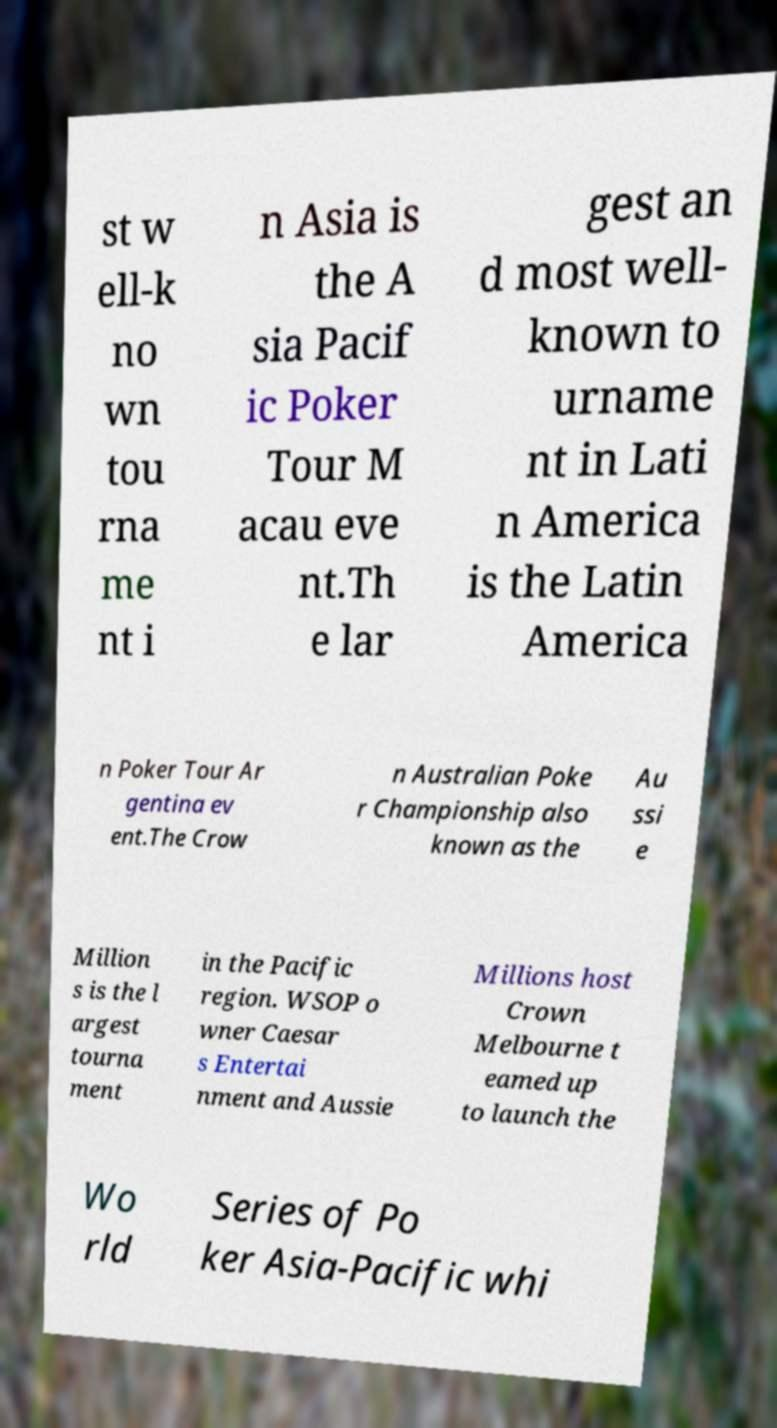Please read and relay the text visible in this image. What does it say? st w ell-k no wn tou rna me nt i n Asia is the A sia Pacif ic Poker Tour M acau eve nt.Th e lar gest an d most well- known to urname nt in Lati n America is the Latin America n Poker Tour Ar gentina ev ent.The Crow n Australian Poke r Championship also known as the Au ssi e Million s is the l argest tourna ment in the Pacific region. WSOP o wner Caesar s Entertai nment and Aussie Millions host Crown Melbourne t eamed up to launch the Wo rld Series of Po ker Asia-Pacific whi 